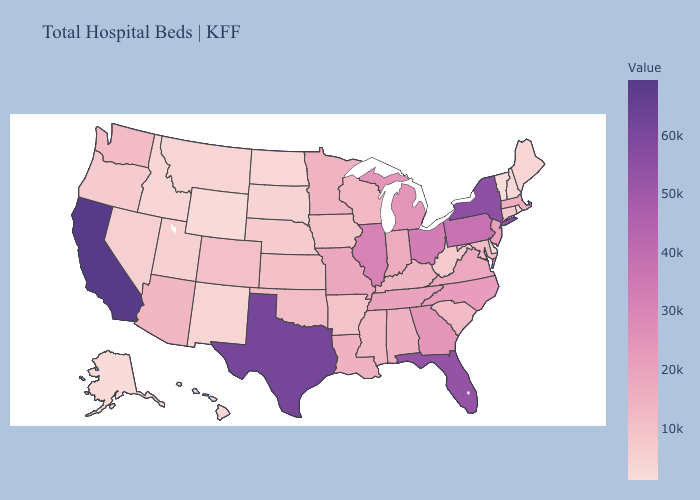Does Pennsylvania have the lowest value in the Northeast?
Concise answer only. No. Does Delaware have the lowest value in the South?
Quick response, please. Yes. Which states have the highest value in the USA?
Be succinct. California. Does Vermont have the lowest value in the Northeast?
Answer briefly. Yes. 